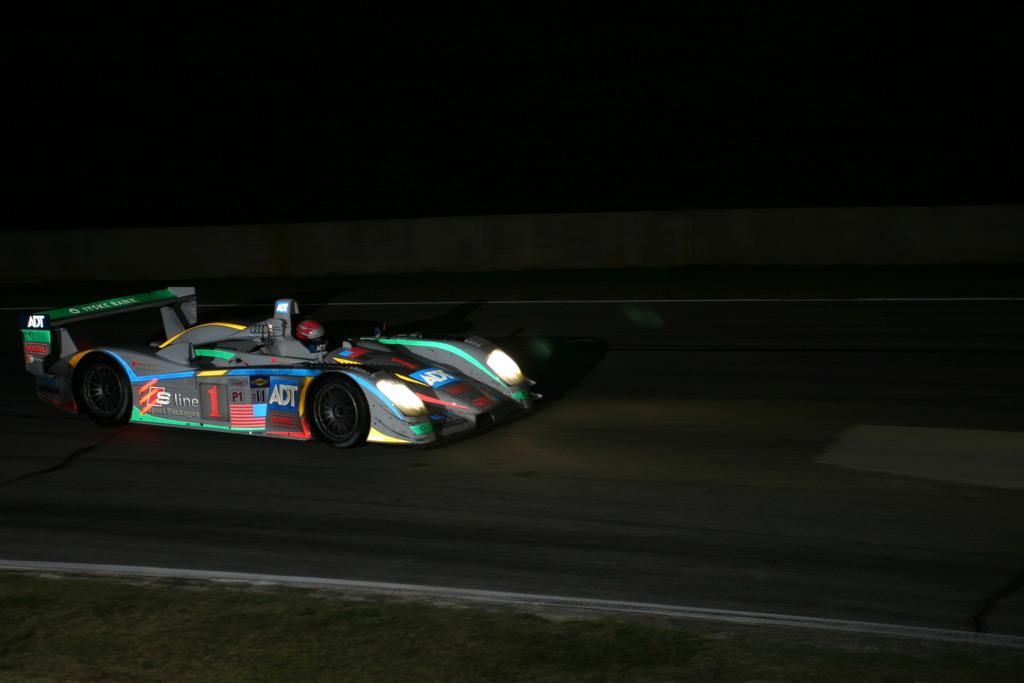What is the main subject of the image? There is a car in the center of the image. Where is the car located? The car is on the road. What can be seen in the background of the image? There are banners in the background of the image. What type of surface is visible at the bottom of the image? Grass is present on the surface at the bottom of the image. What type of guitar is being played by the person in the car? There is no person or guitar present in the image; it only features a car on the road. 